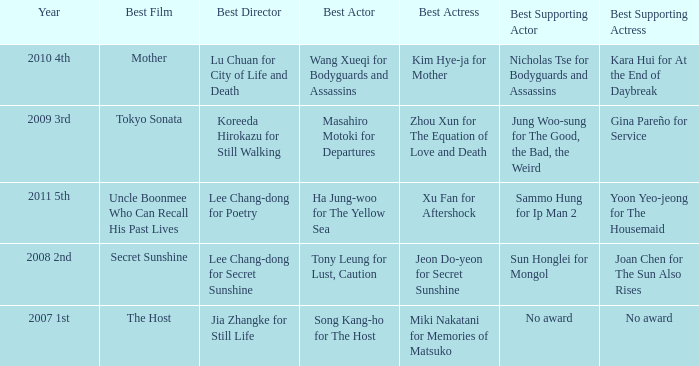Name the best director for mother Lu Chuan for City of Life and Death. 